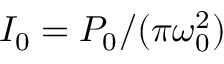Convert formula to latex. <formula><loc_0><loc_0><loc_500><loc_500>I _ { 0 } = P _ { 0 } / ( \pi \omega _ { 0 } ^ { 2 } )</formula> 